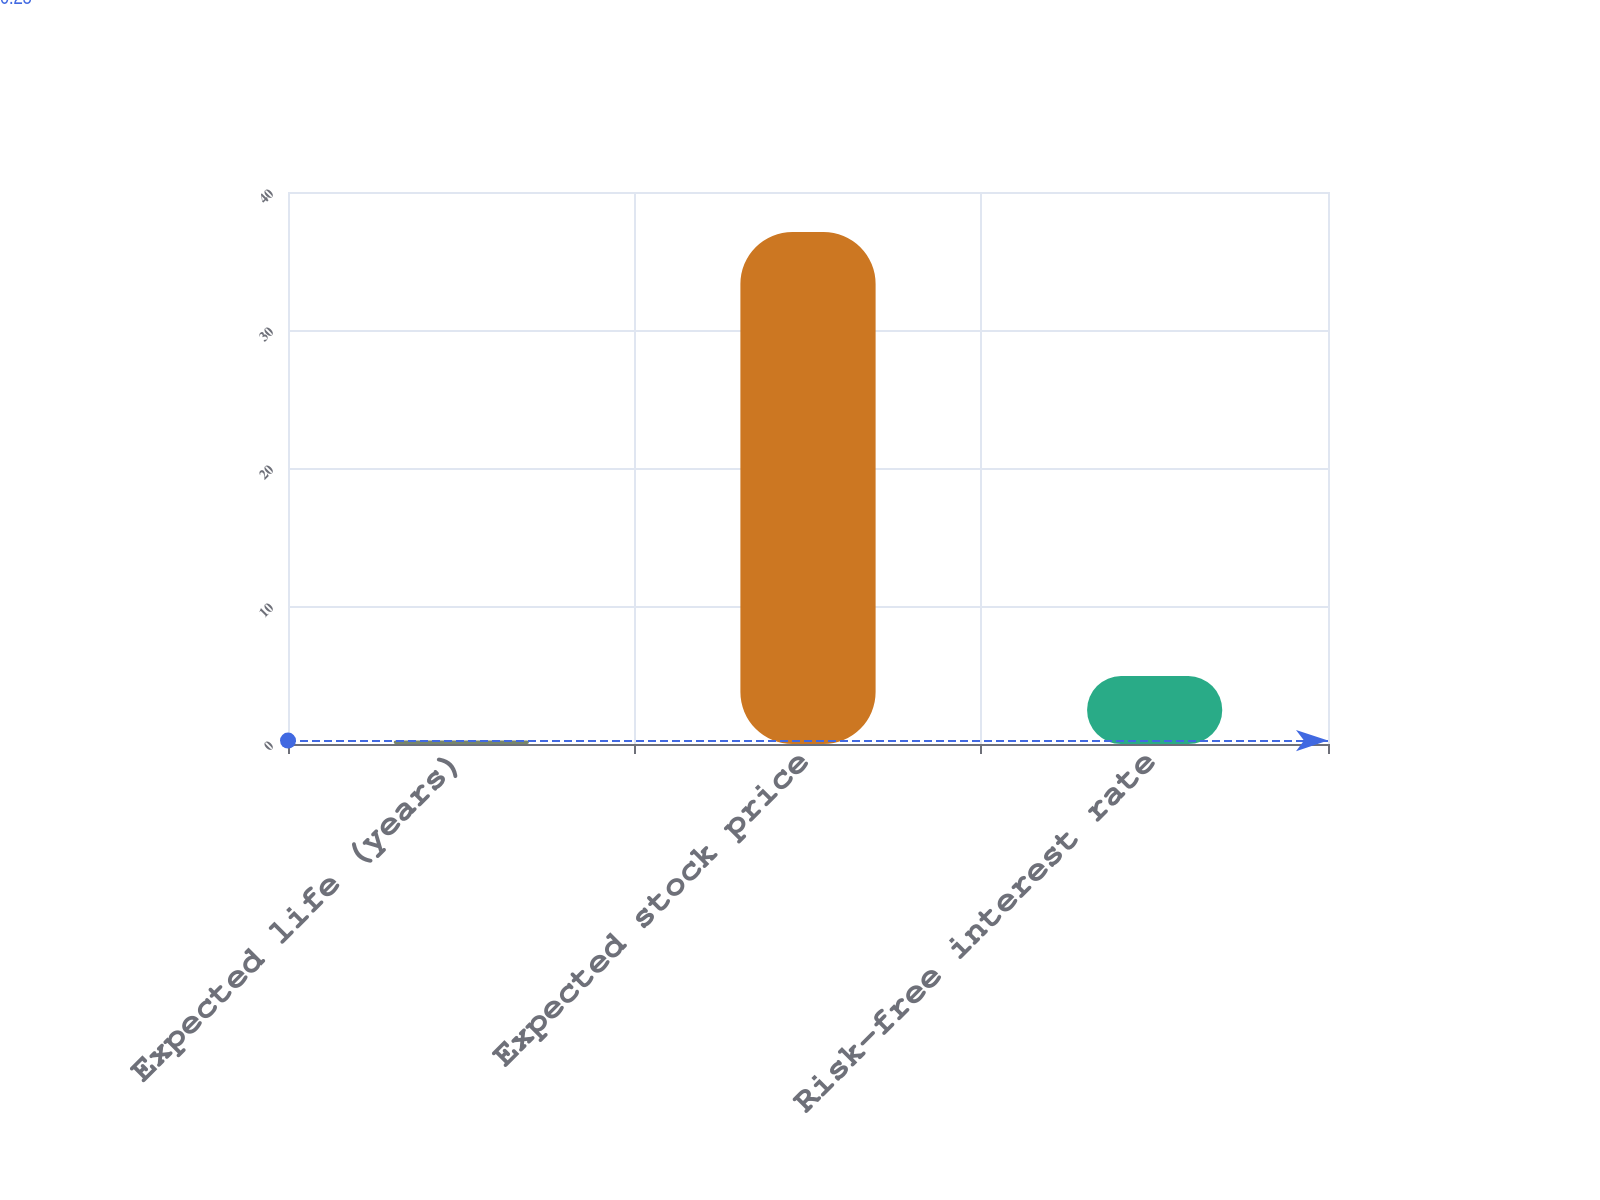<chart> <loc_0><loc_0><loc_500><loc_500><bar_chart><fcel>Expected life (years)<fcel>Expected stock price<fcel>Risk-free interest rate<nl><fcel>0.25<fcel>37.1<fcel>4.92<nl></chart> 